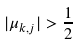Convert formula to latex. <formula><loc_0><loc_0><loc_500><loc_500>| \mu _ { k , j } | > \frac { 1 } { 2 }</formula> 